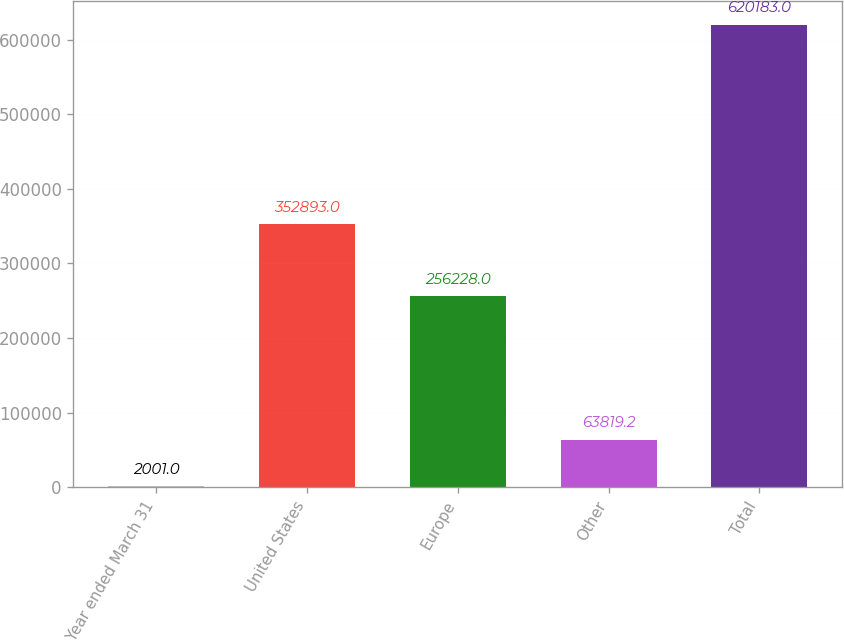<chart> <loc_0><loc_0><loc_500><loc_500><bar_chart><fcel>Year ended March 31<fcel>United States<fcel>Europe<fcel>Other<fcel>Total<nl><fcel>2001<fcel>352893<fcel>256228<fcel>63819.2<fcel>620183<nl></chart> 